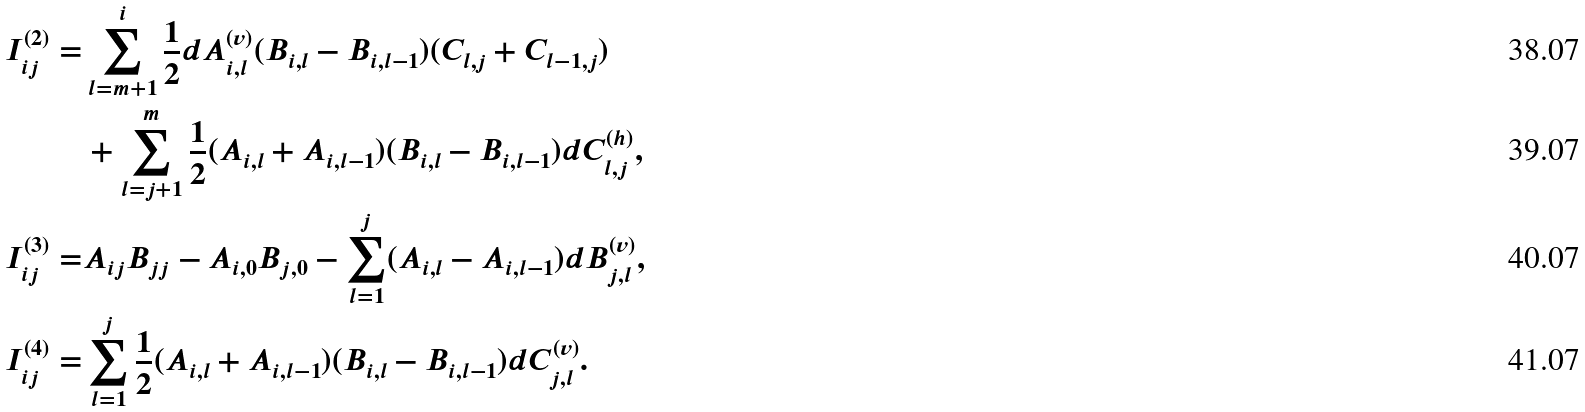<formula> <loc_0><loc_0><loc_500><loc_500>I ^ { ( 2 ) } _ { i j } = & \sum _ { l = m + 1 } ^ { i } \frac { 1 } { 2 } d A ^ { ( v ) } _ { i , l } ( B _ { i , l } - B _ { i , l - 1 } ) ( C _ { l , j } + C _ { l - 1 , j } ) \\ & + \sum _ { l = j + 1 } ^ { m } \frac { 1 } { 2 } ( A _ { i , l } + A _ { i , l - 1 } ) ( B _ { i , l } - B _ { i , l - 1 } ) d C ^ { ( h ) } _ { l , j } , \\ I ^ { ( 3 ) } _ { i j } = & A _ { i j } B _ { j j } - A _ { i , 0 } B _ { j , 0 } - \sum _ { l = 1 } ^ { j } ( A _ { i , l } - A _ { i , l - 1 } ) d B ^ { ( v ) } _ { j , l } , \\ I ^ { ( 4 ) } _ { i j } = & \sum _ { l = 1 } ^ { j } \frac { 1 } { 2 } ( A _ { i , l } + A _ { i , l - 1 } ) ( B _ { i , l } - B _ { i , l - 1 } ) d C ^ { ( v ) } _ { j , l } .</formula> 